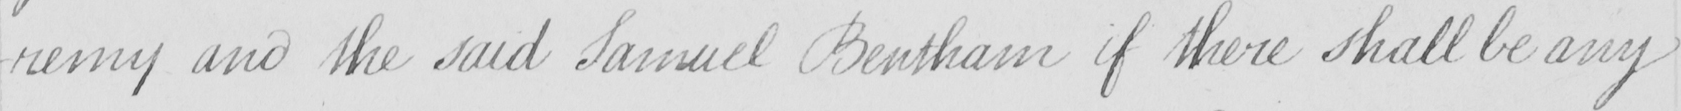Can you tell me what this handwritten text says? -remy and the said Samuel Bentham if there shall be any 